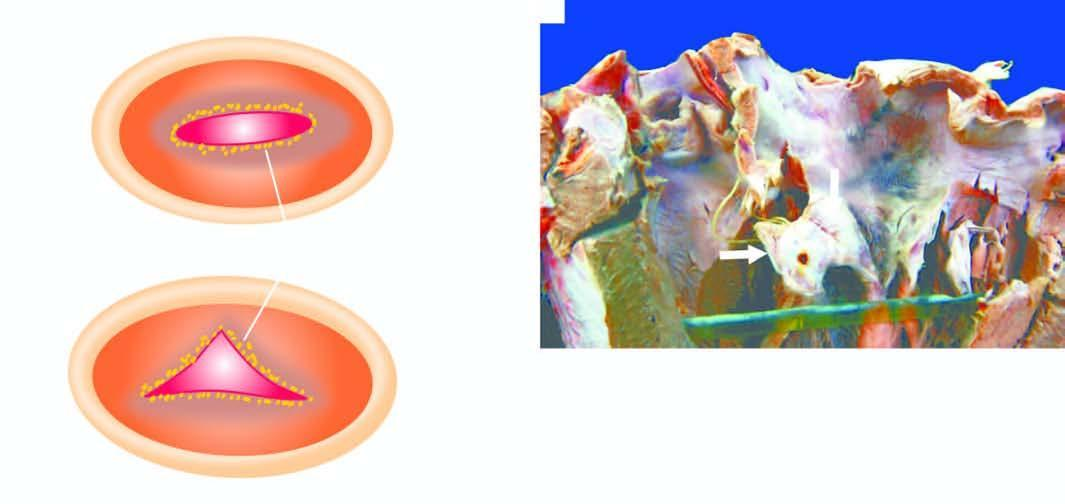what are the location of vegetations on mitral valve shown as?
Answer the question using a single word or phrase. Viewed from the left atrium 